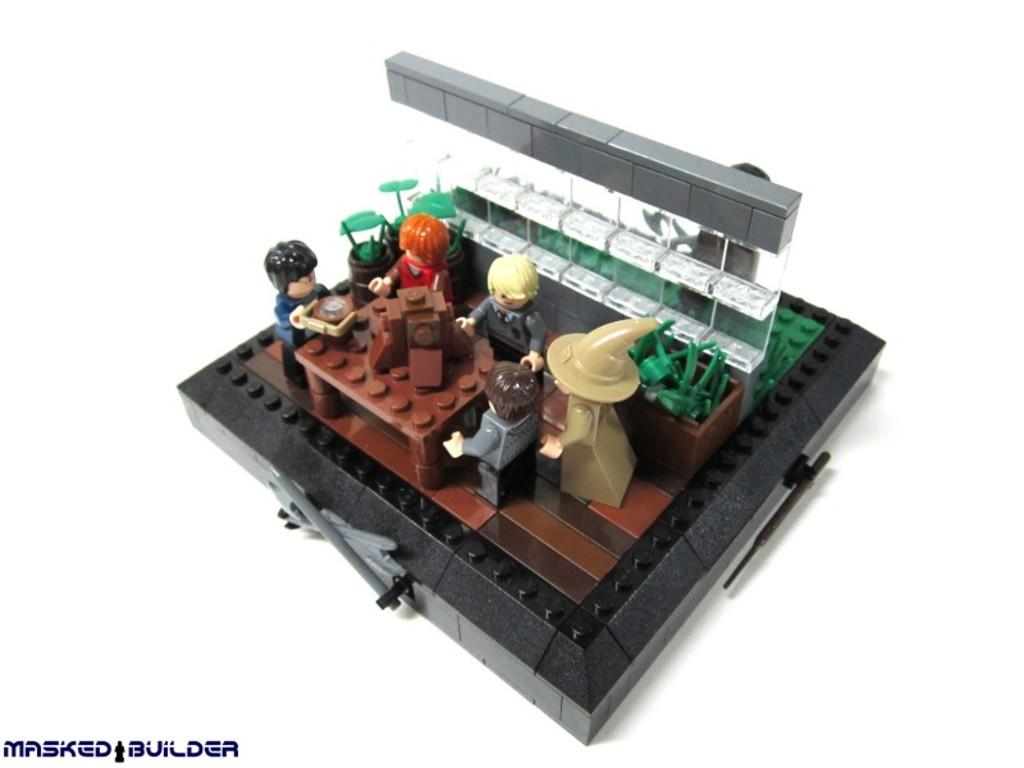What type of object is made of building blocks in the image? There is a toy made of building blocks in the image. Where is the text located in the image? The text is in the bottom left corner of the image. What type of jewel is placed on the toy in the image? There is no jewel present on the toy in the image. How does the bottle look in the image? There is no bottle present in the image. 